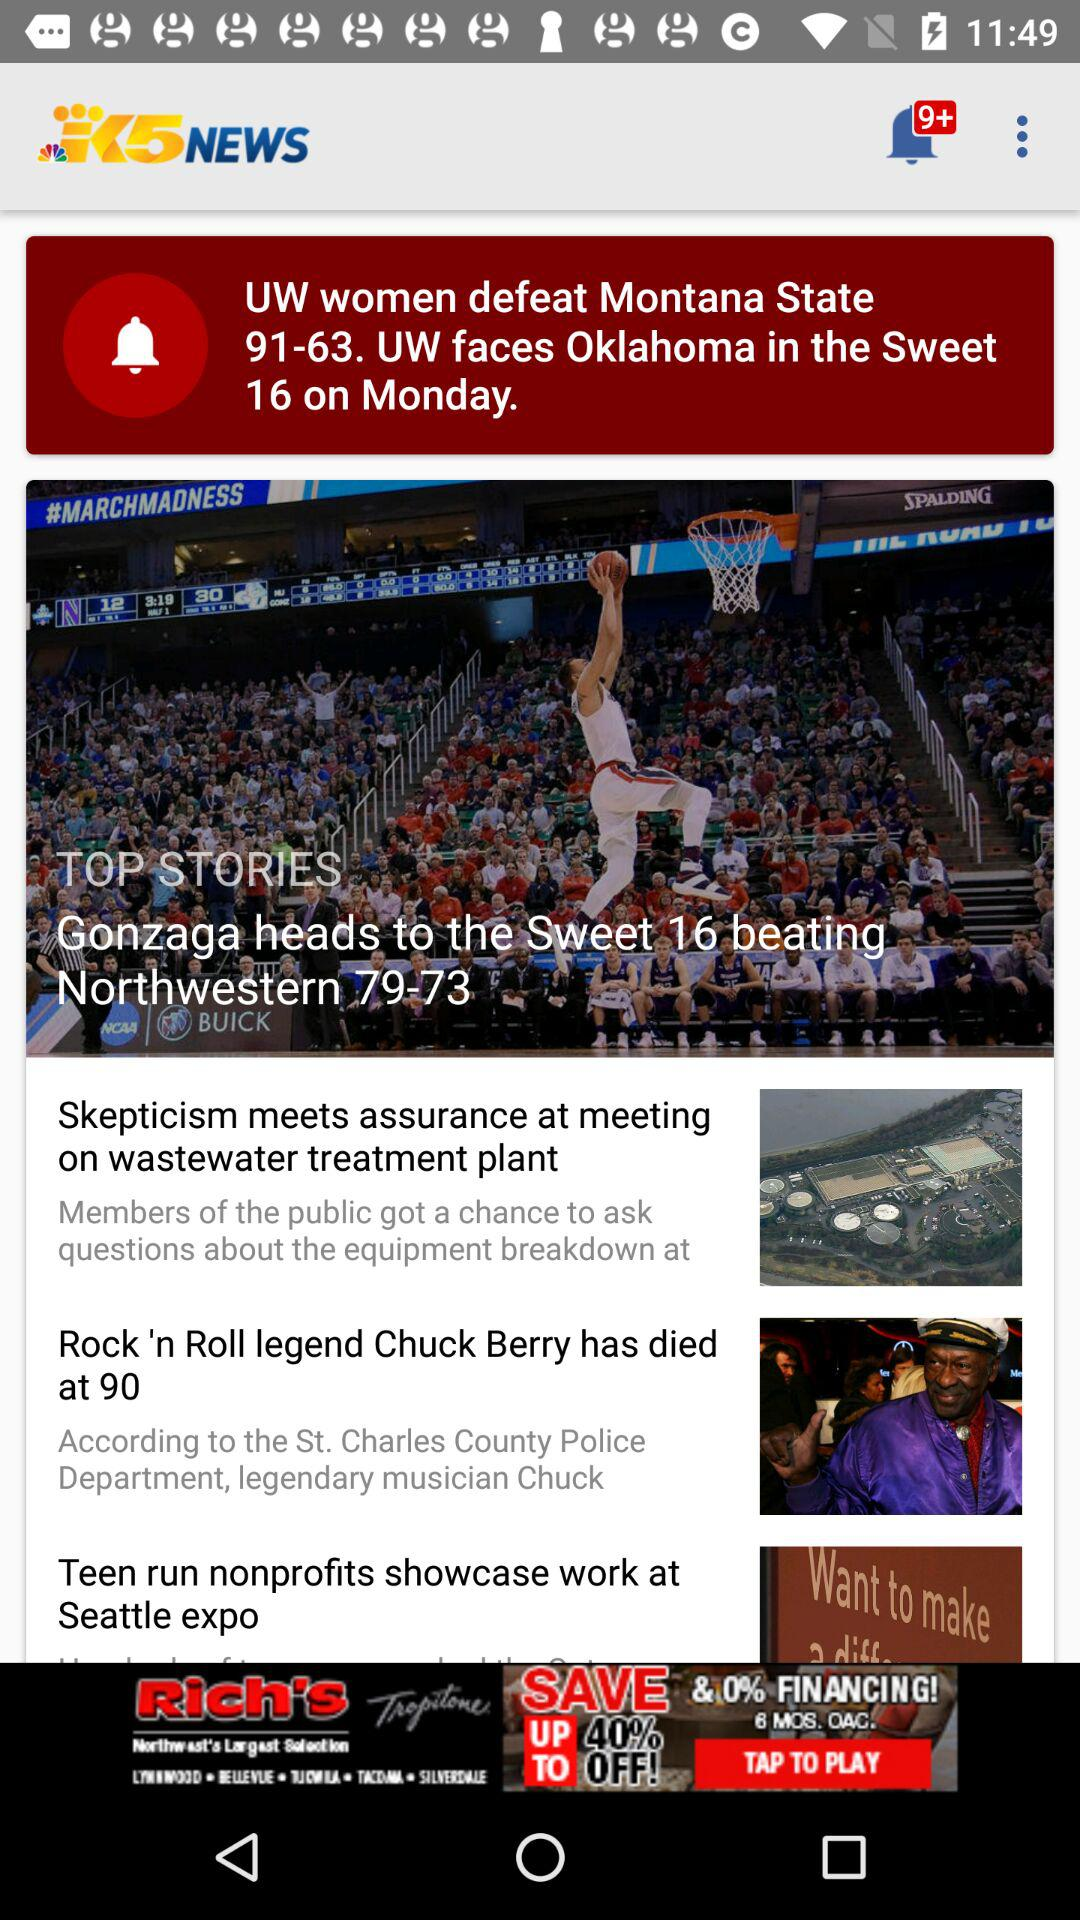By what score did the UW women defeat Montana State? The UW women defeated Montana State by the score of 91-63. 